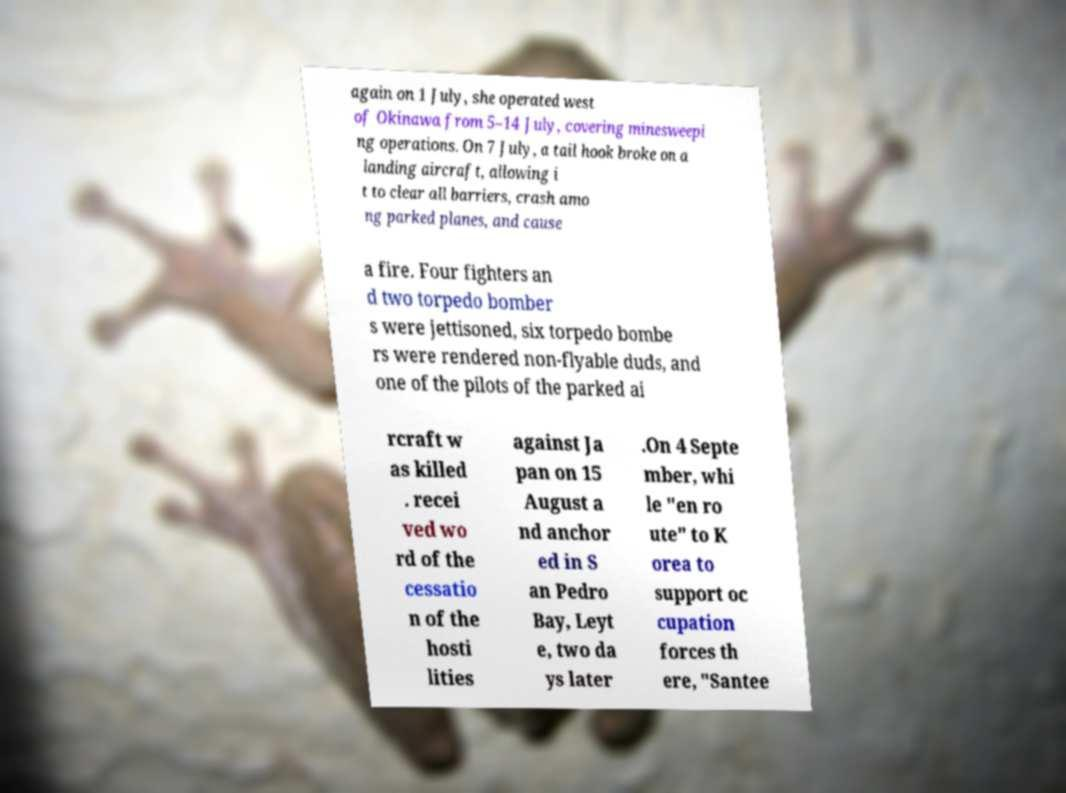I need the written content from this picture converted into text. Can you do that? again on 1 July, she operated west of Okinawa from 5–14 July, covering minesweepi ng operations. On 7 July, a tail hook broke on a landing aircraft, allowing i t to clear all barriers, crash amo ng parked planes, and cause a fire. Four fighters an d two torpedo bomber s were jettisoned, six torpedo bombe rs were rendered non-flyable duds, and one of the pilots of the parked ai rcraft w as killed . recei ved wo rd of the cessatio n of the hosti lities against Ja pan on 15 August a nd anchor ed in S an Pedro Bay, Leyt e, two da ys later .On 4 Septe mber, whi le "en ro ute" to K orea to support oc cupation forces th ere, "Santee 